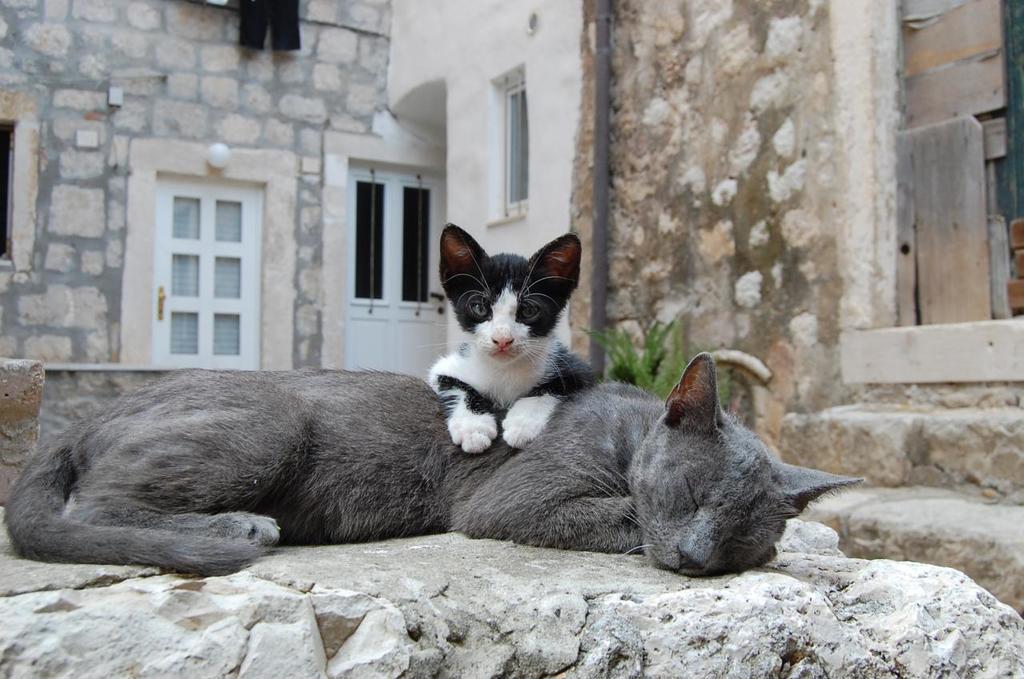In one or two sentences, can you explain what this image depicts? There are two cats. In the background we can see a wall, door, windows, pole, light, and a plant. 